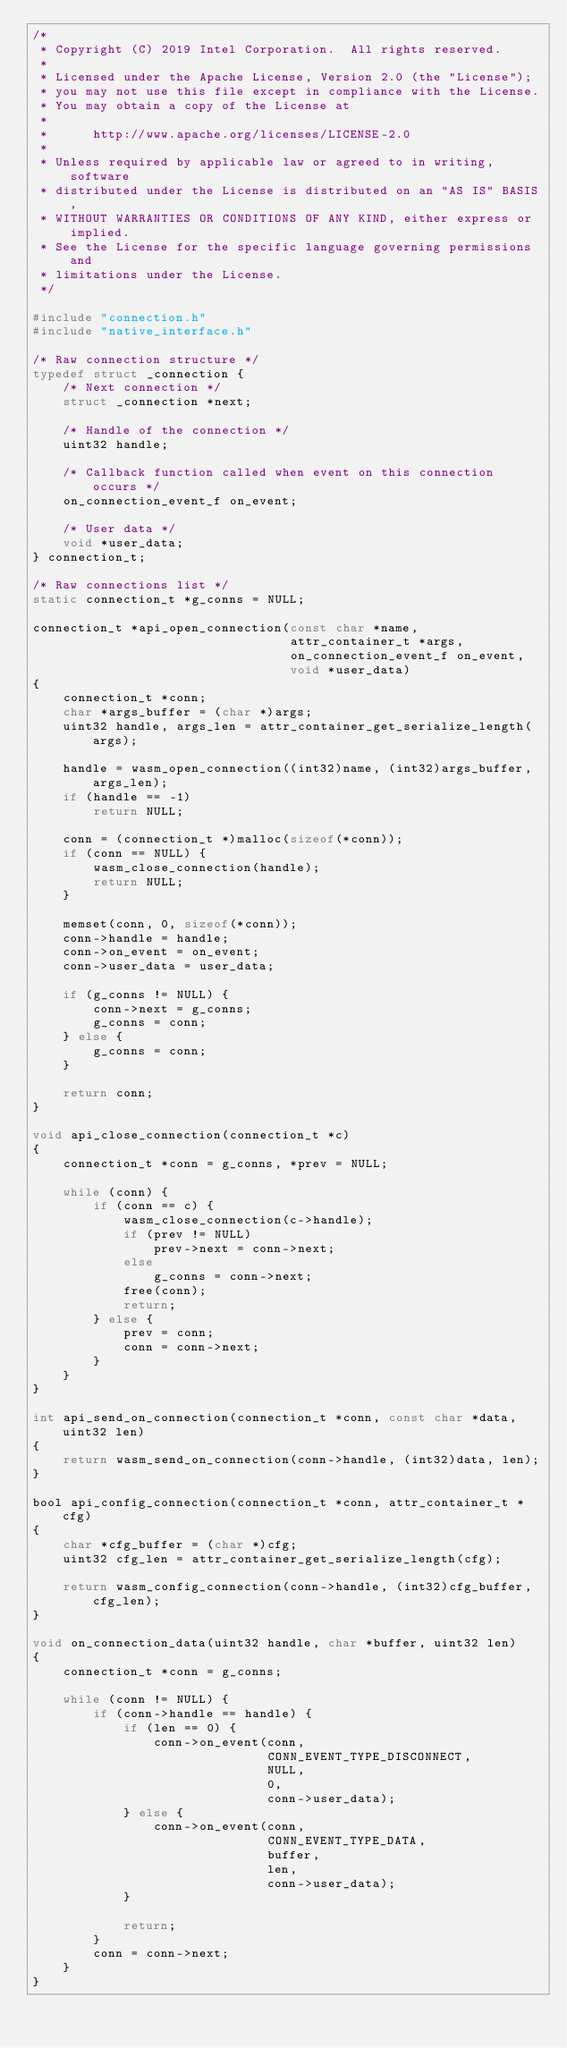Convert code to text. <code><loc_0><loc_0><loc_500><loc_500><_C_>/*
 * Copyright (C) 2019 Intel Corporation.  All rights reserved.
 *
 * Licensed under the Apache License, Version 2.0 (the "License");
 * you may not use this file except in compliance with the License.
 * You may obtain a copy of the License at
 *
 *      http://www.apache.org/licenses/LICENSE-2.0
 *
 * Unless required by applicable law or agreed to in writing, software
 * distributed under the License is distributed on an "AS IS" BASIS,
 * WITHOUT WARRANTIES OR CONDITIONS OF ANY KIND, either express or implied.
 * See the License for the specific language governing permissions and
 * limitations under the License.
 */

#include "connection.h"
#include "native_interface.h"

/* Raw connection structure */
typedef struct _connection {
    /* Next connection */
    struct _connection *next;

    /* Handle of the connection */
    uint32 handle;

    /* Callback function called when event on this connection occurs */
    on_connection_event_f on_event;

    /* User data */
    void *user_data;
} connection_t;

/* Raw connections list */
static connection_t *g_conns = NULL;

connection_t *api_open_connection(const char *name,
                                  attr_container_t *args,
                                  on_connection_event_f on_event,
                                  void *user_data)
{
    connection_t *conn;
    char *args_buffer = (char *)args;
    uint32 handle, args_len = attr_container_get_serialize_length(args);

    handle = wasm_open_connection((int32)name, (int32)args_buffer, args_len);
    if (handle == -1)
        return NULL;

    conn = (connection_t *)malloc(sizeof(*conn));
    if (conn == NULL) {
        wasm_close_connection(handle);
        return NULL;
    }

    memset(conn, 0, sizeof(*conn));
    conn->handle = handle;
    conn->on_event = on_event;
    conn->user_data = user_data;

    if (g_conns != NULL) {
        conn->next = g_conns;
        g_conns = conn;
    } else {
        g_conns = conn;
    }

    return conn;
}

void api_close_connection(connection_t *c)
{
    connection_t *conn = g_conns, *prev = NULL;

    while (conn) {
        if (conn == c) {
            wasm_close_connection(c->handle);
            if (prev != NULL)
                prev->next = conn->next;
            else
                g_conns = conn->next;
            free(conn);
            return;
        } else {
            prev = conn;
            conn = conn->next;
        }
    }
}

int api_send_on_connection(connection_t *conn, const char *data, uint32 len)
{
    return wasm_send_on_connection(conn->handle, (int32)data, len);
}

bool api_config_connection(connection_t *conn, attr_container_t *cfg)
{
    char *cfg_buffer = (char *)cfg;
    uint32 cfg_len = attr_container_get_serialize_length(cfg);

    return wasm_config_connection(conn->handle, (int32)cfg_buffer, cfg_len);
}

void on_connection_data(uint32 handle, char *buffer, uint32 len)
{
    connection_t *conn = g_conns;

    while (conn != NULL) {
        if (conn->handle == handle) {
            if (len == 0) {
                conn->on_event(conn,
                               CONN_EVENT_TYPE_DISCONNECT,
                               NULL,
                               0,
                               conn->user_data);
            } else {
                conn->on_event(conn,
                               CONN_EVENT_TYPE_DATA,
                               buffer,
                               len,
                               conn->user_data);
            }

            return;
        }
        conn = conn->next;
    }
}

</code> 